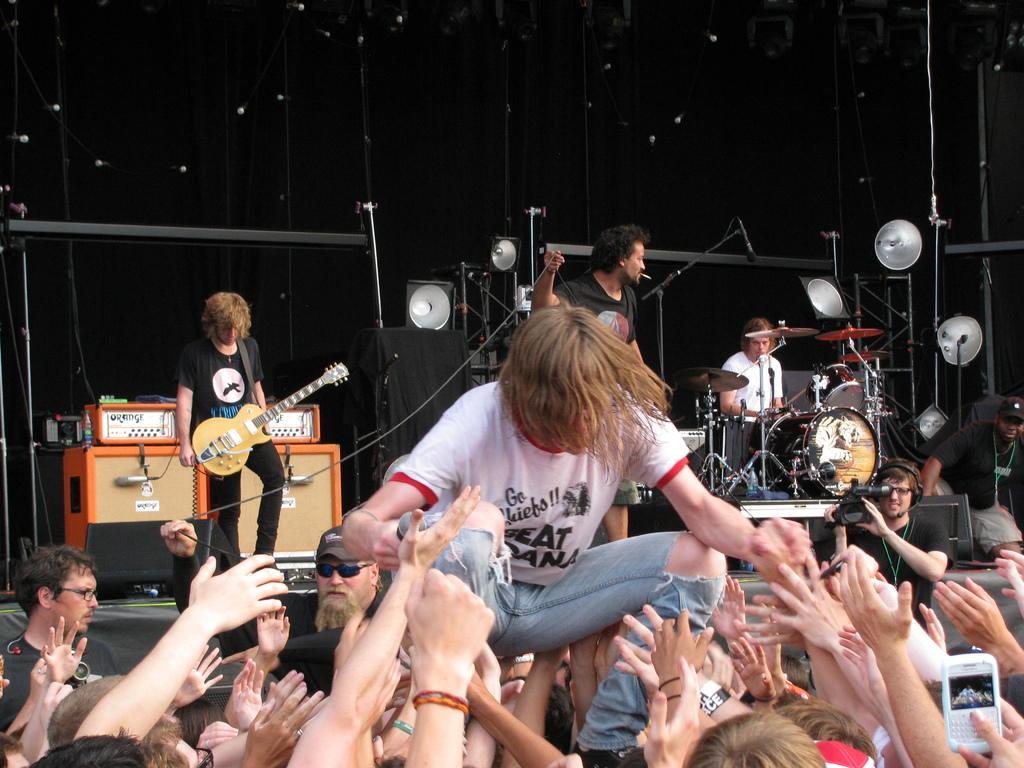How would you summarize this image in a sentence or two? a music concert is going on. there are people standing. behind them a person at the left is holding guitar. the person at the left is holding guitar. the person at the front is playing drums. 